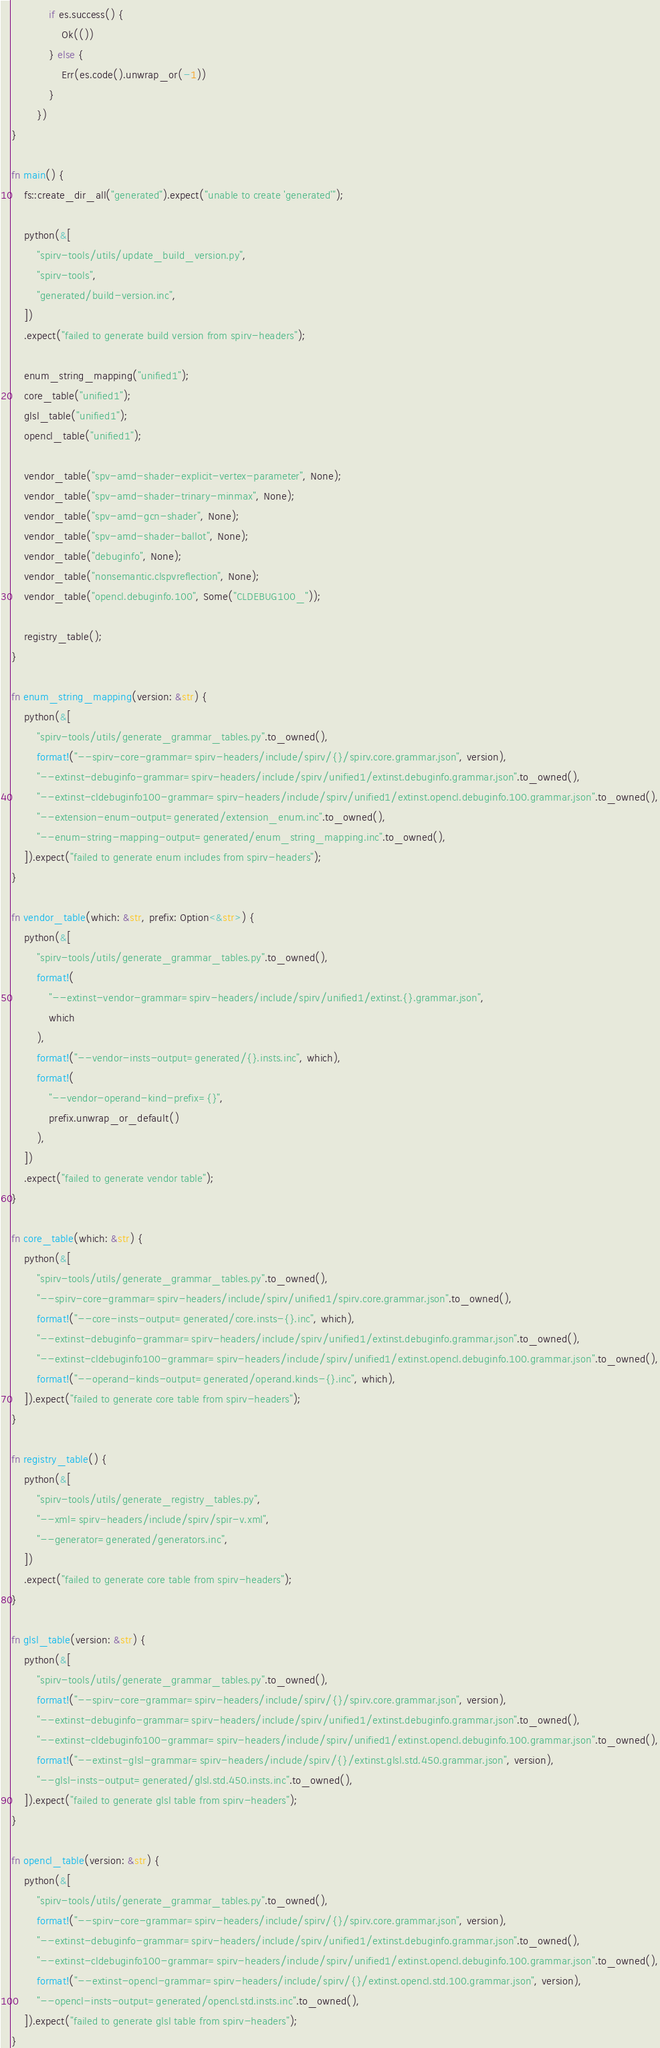<code> <loc_0><loc_0><loc_500><loc_500><_Rust_>            if es.success() {
                Ok(())
            } else {
                Err(es.code().unwrap_or(-1))
            }
        })
}

fn main() {
    fs::create_dir_all("generated").expect("unable to create 'generated'");

    python(&[
        "spirv-tools/utils/update_build_version.py",
        "spirv-tools",
        "generated/build-version.inc",
    ])
    .expect("failed to generate build version from spirv-headers");

    enum_string_mapping("unified1");
    core_table("unified1");
    glsl_table("unified1");
    opencl_table("unified1");

    vendor_table("spv-amd-shader-explicit-vertex-parameter", None);
    vendor_table("spv-amd-shader-trinary-minmax", None);
    vendor_table("spv-amd-gcn-shader", None);
    vendor_table("spv-amd-shader-ballot", None);
    vendor_table("debuginfo", None);
    vendor_table("nonsemantic.clspvreflection", None);
    vendor_table("opencl.debuginfo.100", Some("CLDEBUG100_"));

    registry_table();
}

fn enum_string_mapping(version: &str) {
    python(&[
        "spirv-tools/utils/generate_grammar_tables.py".to_owned(),
        format!("--spirv-core-grammar=spirv-headers/include/spirv/{}/spirv.core.grammar.json", version),
        "--extinst-debuginfo-grammar=spirv-headers/include/spirv/unified1/extinst.debuginfo.grammar.json".to_owned(),
        "--extinst-cldebuginfo100-grammar=spirv-headers/include/spirv/unified1/extinst.opencl.debuginfo.100.grammar.json".to_owned(),
        "--extension-enum-output=generated/extension_enum.inc".to_owned(),
        "--enum-string-mapping-output=generated/enum_string_mapping.inc".to_owned(),
    ]).expect("failed to generate enum includes from spirv-headers");
}

fn vendor_table(which: &str, prefix: Option<&str>) {
    python(&[
        "spirv-tools/utils/generate_grammar_tables.py".to_owned(),
        format!(
            "--extinst-vendor-grammar=spirv-headers/include/spirv/unified1/extinst.{}.grammar.json",
            which
        ),
        format!("--vendor-insts-output=generated/{}.insts.inc", which),
        format!(
            "--vendor-operand-kind-prefix={}",
            prefix.unwrap_or_default()
        ),
    ])
    .expect("failed to generate vendor table");
}

fn core_table(which: &str) {
    python(&[
        "spirv-tools/utils/generate_grammar_tables.py".to_owned(),
        "--spirv-core-grammar=spirv-headers/include/spirv/unified1/spirv.core.grammar.json".to_owned(),
        format!("--core-insts-output=generated/core.insts-{}.inc", which),
        "--extinst-debuginfo-grammar=spirv-headers/include/spirv/unified1/extinst.debuginfo.grammar.json".to_owned(),
        "--extinst-cldebuginfo100-grammar=spirv-headers/include/spirv/unified1/extinst.opencl.debuginfo.100.grammar.json".to_owned(),
        format!("--operand-kinds-output=generated/operand.kinds-{}.inc", which),
    ]).expect("failed to generate core table from spirv-headers");
}

fn registry_table() {
    python(&[
        "spirv-tools/utils/generate_registry_tables.py",
        "--xml=spirv-headers/include/spirv/spir-v.xml",
        "--generator=generated/generators.inc",
    ])
    .expect("failed to generate core table from spirv-headers");
}

fn glsl_table(version: &str) {
    python(&[
        "spirv-tools/utils/generate_grammar_tables.py".to_owned(),
        format!("--spirv-core-grammar=spirv-headers/include/spirv/{}/spirv.core.grammar.json", version),
        "--extinst-debuginfo-grammar=spirv-headers/include/spirv/unified1/extinst.debuginfo.grammar.json".to_owned(),
        "--extinst-cldebuginfo100-grammar=spirv-headers/include/spirv/unified1/extinst.opencl.debuginfo.100.grammar.json".to_owned(),
        format!("--extinst-glsl-grammar=spirv-headers/include/spirv/{}/extinst.glsl.std.450.grammar.json", version),
        "--glsl-insts-output=generated/glsl.std.450.insts.inc".to_owned(),
    ]).expect("failed to generate glsl table from spirv-headers");
}

fn opencl_table(version: &str) {
    python(&[
        "spirv-tools/utils/generate_grammar_tables.py".to_owned(),
        format!("--spirv-core-grammar=spirv-headers/include/spirv/{}/spirv.core.grammar.json", version),
        "--extinst-debuginfo-grammar=spirv-headers/include/spirv/unified1/extinst.debuginfo.grammar.json".to_owned(),
        "--extinst-cldebuginfo100-grammar=spirv-headers/include/spirv/unified1/extinst.opencl.debuginfo.100.grammar.json".to_owned(),
        format!("--extinst-opencl-grammar=spirv-headers/include/spirv/{}/extinst.opencl.std.100.grammar.json", version),
        "--opencl-insts-output=generated/opencl.std.insts.inc".to_owned(),
    ]).expect("failed to generate glsl table from spirv-headers");
}
</code> 